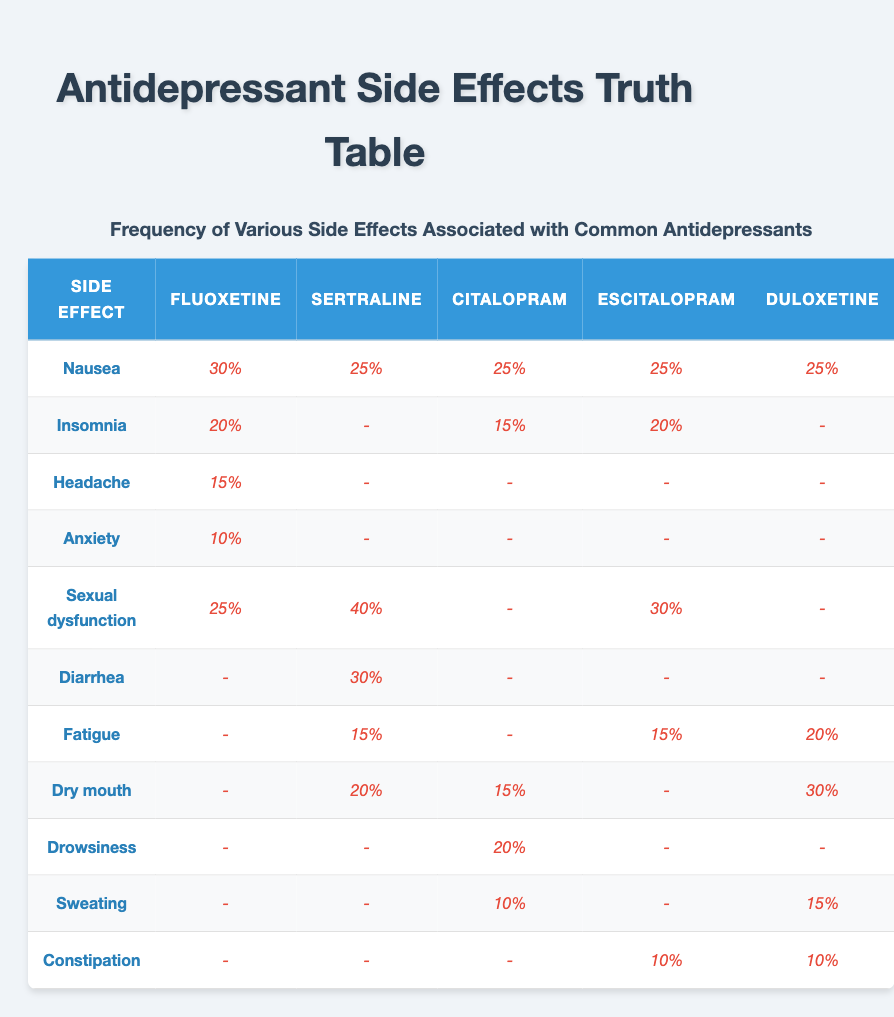What is the frequency of Nausea for Fluoxetine? According to the table, the frequency of Nausea for Fluoxetine is listed as 30% in the corresponding row and column.
Answer: 30% Which antidepressant has the highest frequency of Sexual dysfunction? By examining the Sexual dysfunction row across the antidepressants, Sertraline shows the highest frequency at 40%.
Answer: Sertraline What percentage of fluoxetine users experience Insomnia or Anxiety? For Fluoxetine, Insomnia has a frequency of 20% and Anxiety is 10%. Adding these values together gives 20% + 10% = 30%.
Answer: 30% Is there any antidepressant that has a frequency of more than 20% for Dry mouth? By checking the Dry mouth row, we see that Duloxetine has a frequency of 30%, which is greater than 20%. Therefore, the statement is true.
Answer: Yes What is the total frequency of side effects for Citalopram? Citalopram lists the following frequencies: 25% (Nausea) + 15% (Dry mouth) + 20% (Drowsiness) + 15% (Insomnia) + 10% (Sweating) = 95%.
Answer: 95% Which antidepressant has the lowest frequency for the side effect Sweating? Looking at the Sweating row, Citalopram has the lowest frequency at 10%, while Duloxetine has 15%.
Answer: Citalopram How many antidepressants have a frequency of 25% or higher for Nausea? The Nausea effect shows frequencies of 30% (Fluoxetine) and 25% (Sertraline), 25% (Citalopram), 25% (Escitalopram), and 25% (Duloxetine), totaling 5 antidepressants at or above 25%.
Answer: 5 What is the average frequency of Insomnia across all antidepressants listed? Insomnia has reported frequencies of 20% (Fluoxetine), 15% (Citalopram), and 20% (Escitalopram). Therefore, the average is (20 + 15 + 20) / 3 = 55 / 3 = 18.33% rounded to two decimal places.
Answer: 18.33% Does any antidepressant have a side effect of Drowsiness at a frequency greater than 10%? The Drowsiness frequency for Citalopram is 20%, which is greater than 10%, confirming that the statement is true.
Answer: Yes 